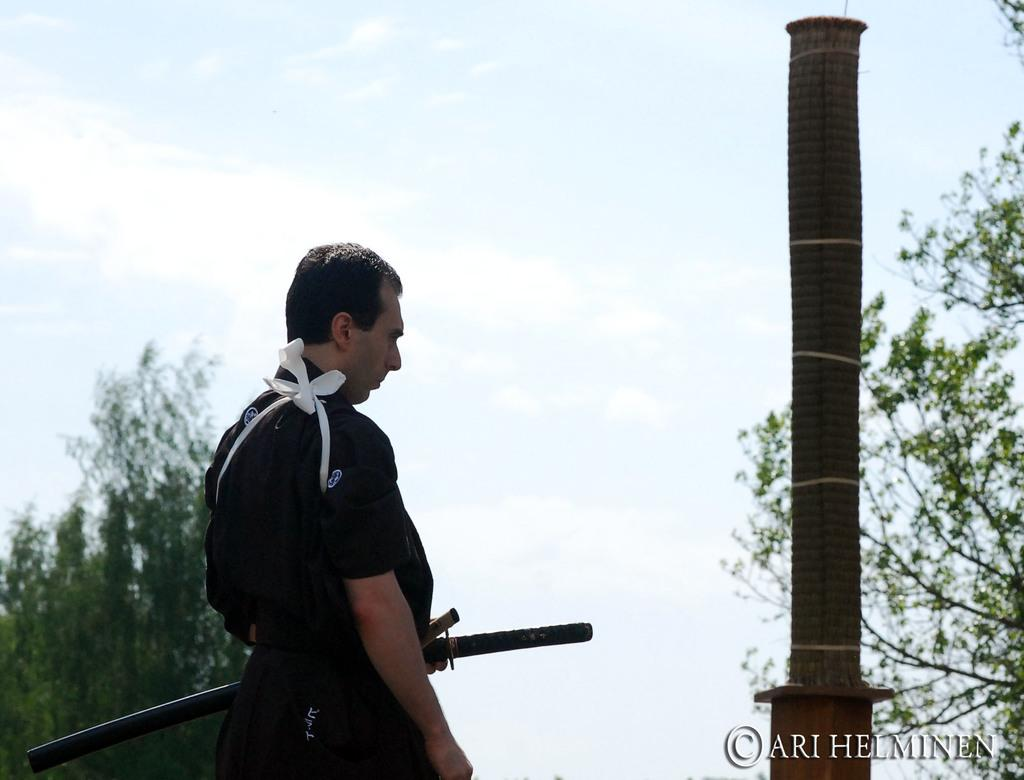Who is present in the image? There is a man in the image. Where is the man located in the image? The man is on the left side of the image. What is the man holding in his hand? The man is holding a sword in his hand. What can be seen in the background of the image? There are trees, poles, and clouds in the sky in the background of the image. What type of comb is the man using to style his hair in the image? There is no comb visible in the image, and the man's hair is not being styled. 